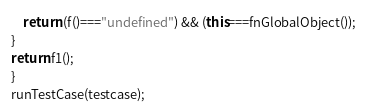Convert code to text. <code><loc_0><loc_0><loc_500><loc_500><_JavaScript_>    return (f()==="undefined") && (this===fnGlobalObject());
}
return f1();
}
runTestCase(testcase);</code> 